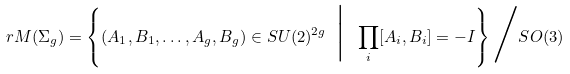Convert formula to latex. <formula><loc_0><loc_0><loc_500><loc_500>r M ( \Sigma _ { g } ) = \left \{ ( A _ { 1 } , B _ { 1 } , \dots , A _ { g } , B _ { g } ) \in S U ( 2 ) ^ { 2 g } \ \Big | \ \prod _ { i } [ A _ { i } , B _ { i } ] = - I \right \} \Big / S O ( 3 )</formula> 